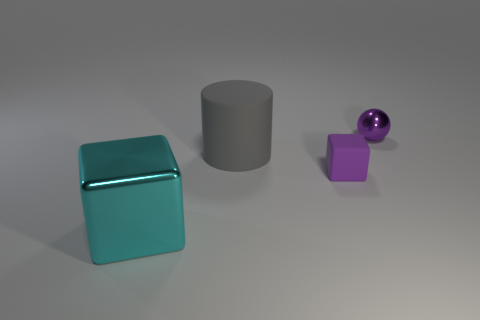Add 3 small cyan metal spheres. How many objects exist? 7 Subtract all spheres. How many objects are left? 3 Add 1 rubber things. How many rubber things are left? 3 Add 1 tiny objects. How many tiny objects exist? 3 Subtract 0 purple cylinders. How many objects are left? 4 Subtract all tiny brown matte cylinders. Subtract all small purple objects. How many objects are left? 2 